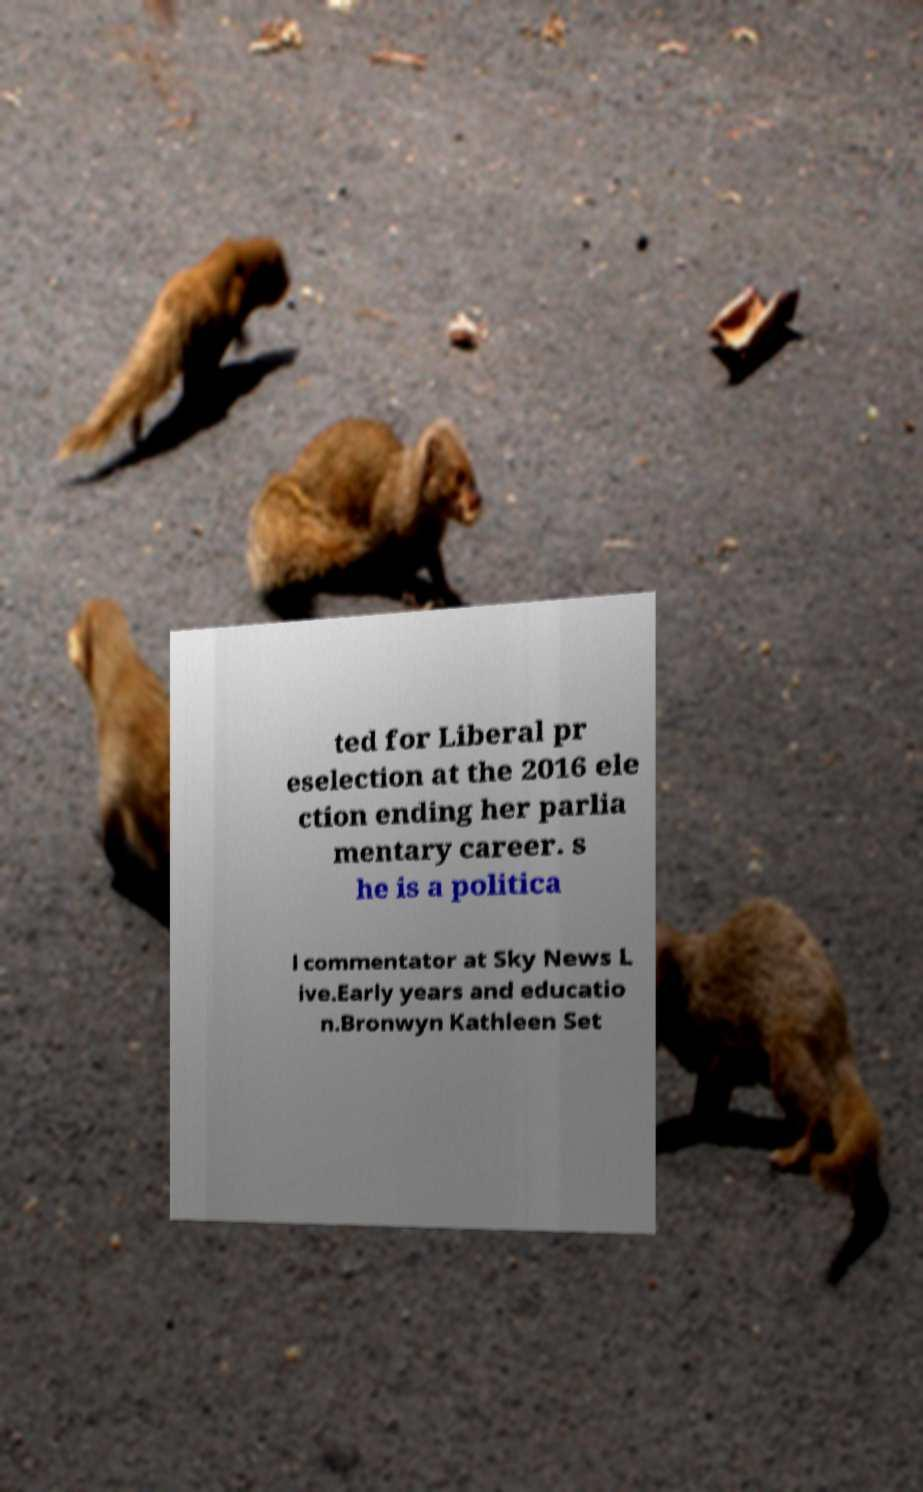There's text embedded in this image that I need extracted. Can you transcribe it verbatim? ted for Liberal pr eselection at the 2016 ele ction ending her parlia mentary career. s he is a politica l commentator at Sky News L ive.Early years and educatio n.Bronwyn Kathleen Set 